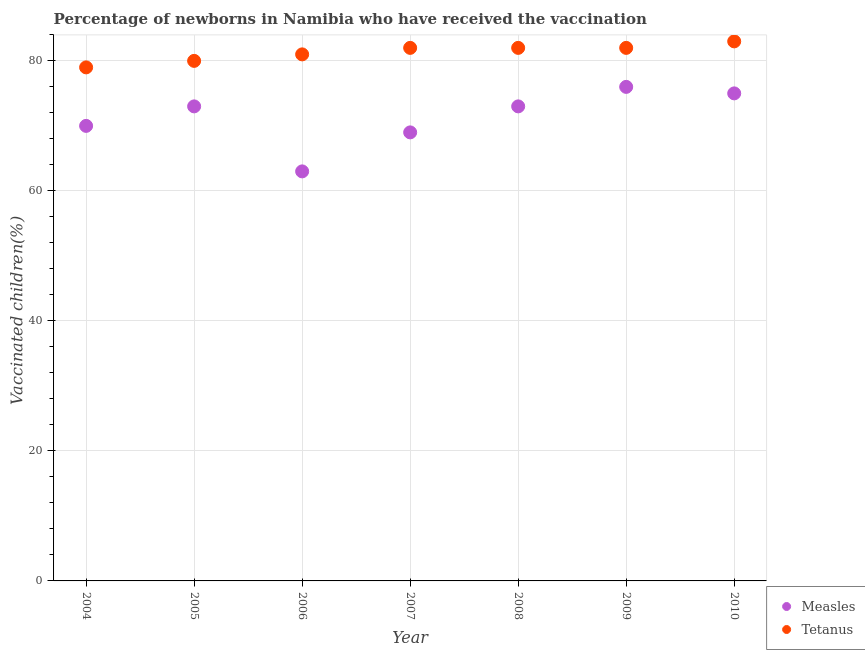Is the number of dotlines equal to the number of legend labels?
Offer a very short reply. Yes. What is the percentage of newborns who received vaccination for tetanus in 2006?
Ensure brevity in your answer.  81. Across all years, what is the maximum percentage of newborns who received vaccination for measles?
Provide a short and direct response. 76. Across all years, what is the minimum percentage of newborns who received vaccination for measles?
Give a very brief answer. 63. In which year was the percentage of newborns who received vaccination for tetanus maximum?
Your answer should be compact. 2010. In which year was the percentage of newborns who received vaccination for measles minimum?
Your answer should be very brief. 2006. What is the total percentage of newborns who received vaccination for measles in the graph?
Provide a succinct answer. 499. What is the difference between the percentage of newborns who received vaccination for tetanus in 2006 and that in 2009?
Give a very brief answer. -1. What is the difference between the percentage of newborns who received vaccination for measles in 2010 and the percentage of newborns who received vaccination for tetanus in 2005?
Offer a terse response. -5. What is the average percentage of newborns who received vaccination for measles per year?
Keep it short and to the point. 71.29. In the year 2009, what is the difference between the percentage of newborns who received vaccination for measles and percentage of newborns who received vaccination for tetanus?
Your answer should be compact. -6. What is the ratio of the percentage of newborns who received vaccination for measles in 2007 to that in 2010?
Your answer should be compact. 0.92. Is the percentage of newborns who received vaccination for measles in 2008 less than that in 2009?
Ensure brevity in your answer.  Yes. What is the difference between the highest and the second highest percentage of newborns who received vaccination for tetanus?
Offer a terse response. 1. What is the difference between the highest and the lowest percentage of newborns who received vaccination for measles?
Offer a terse response. 13. Is the sum of the percentage of newborns who received vaccination for measles in 2008 and 2009 greater than the maximum percentage of newborns who received vaccination for tetanus across all years?
Provide a short and direct response. Yes. Is the percentage of newborns who received vaccination for measles strictly less than the percentage of newborns who received vaccination for tetanus over the years?
Give a very brief answer. Yes. Are the values on the major ticks of Y-axis written in scientific E-notation?
Keep it short and to the point. No. Does the graph contain grids?
Your response must be concise. Yes. How are the legend labels stacked?
Your answer should be very brief. Vertical. What is the title of the graph?
Your answer should be very brief. Percentage of newborns in Namibia who have received the vaccination. Does "Urban" appear as one of the legend labels in the graph?
Offer a very short reply. No. What is the label or title of the X-axis?
Keep it short and to the point. Year. What is the label or title of the Y-axis?
Provide a short and direct response. Vaccinated children(%)
. What is the Vaccinated children(%)
 in Measles in 2004?
Ensure brevity in your answer.  70. What is the Vaccinated children(%)
 of Tetanus in 2004?
Keep it short and to the point. 79. What is the Vaccinated children(%)
 in Measles in 2005?
Give a very brief answer. 73. What is the Vaccinated children(%)
 of Tetanus in 2005?
Keep it short and to the point. 80. What is the Vaccinated children(%)
 of Tetanus in 2008?
Your answer should be very brief. 82. What is the Vaccinated children(%)
 of Tetanus in 2009?
Provide a succinct answer. 82. What is the Vaccinated children(%)
 of Measles in 2010?
Give a very brief answer. 75. What is the Vaccinated children(%)
 of Tetanus in 2010?
Ensure brevity in your answer.  83. Across all years, what is the maximum Vaccinated children(%)
 of Measles?
Provide a short and direct response. 76. Across all years, what is the minimum Vaccinated children(%)
 of Tetanus?
Your answer should be compact. 79. What is the total Vaccinated children(%)
 of Measles in the graph?
Your response must be concise. 499. What is the total Vaccinated children(%)
 in Tetanus in the graph?
Provide a short and direct response. 569. What is the difference between the Vaccinated children(%)
 of Measles in 2004 and that in 2005?
Make the answer very short. -3. What is the difference between the Vaccinated children(%)
 in Tetanus in 2004 and that in 2005?
Ensure brevity in your answer.  -1. What is the difference between the Vaccinated children(%)
 of Tetanus in 2004 and that in 2006?
Offer a very short reply. -2. What is the difference between the Vaccinated children(%)
 of Measles in 2004 and that in 2008?
Ensure brevity in your answer.  -3. What is the difference between the Vaccinated children(%)
 of Measles in 2004 and that in 2009?
Your answer should be compact. -6. What is the difference between the Vaccinated children(%)
 of Tetanus in 2004 and that in 2009?
Provide a succinct answer. -3. What is the difference between the Vaccinated children(%)
 of Tetanus in 2004 and that in 2010?
Provide a short and direct response. -4. What is the difference between the Vaccinated children(%)
 of Measles in 2005 and that in 2006?
Your answer should be very brief. 10. What is the difference between the Vaccinated children(%)
 in Tetanus in 2005 and that in 2007?
Give a very brief answer. -2. What is the difference between the Vaccinated children(%)
 in Tetanus in 2005 and that in 2008?
Offer a terse response. -2. What is the difference between the Vaccinated children(%)
 of Tetanus in 2005 and that in 2009?
Ensure brevity in your answer.  -2. What is the difference between the Vaccinated children(%)
 of Measles in 2005 and that in 2010?
Provide a succinct answer. -2. What is the difference between the Vaccinated children(%)
 of Measles in 2006 and that in 2007?
Provide a succinct answer. -6. What is the difference between the Vaccinated children(%)
 in Tetanus in 2006 and that in 2007?
Ensure brevity in your answer.  -1. What is the difference between the Vaccinated children(%)
 of Measles in 2006 and that in 2008?
Make the answer very short. -10. What is the difference between the Vaccinated children(%)
 of Tetanus in 2006 and that in 2009?
Your answer should be compact. -1. What is the difference between the Vaccinated children(%)
 of Measles in 2007 and that in 2008?
Ensure brevity in your answer.  -4. What is the difference between the Vaccinated children(%)
 in Measles in 2007 and that in 2009?
Provide a succinct answer. -7. What is the difference between the Vaccinated children(%)
 in Tetanus in 2007 and that in 2009?
Give a very brief answer. 0. What is the difference between the Vaccinated children(%)
 in Measles in 2007 and that in 2010?
Keep it short and to the point. -6. What is the difference between the Vaccinated children(%)
 of Tetanus in 2007 and that in 2010?
Offer a very short reply. -1. What is the difference between the Vaccinated children(%)
 in Measles in 2008 and that in 2009?
Your answer should be very brief. -3. What is the difference between the Vaccinated children(%)
 of Measles in 2004 and the Vaccinated children(%)
 of Tetanus in 2005?
Your answer should be compact. -10. What is the difference between the Vaccinated children(%)
 of Measles in 2004 and the Vaccinated children(%)
 of Tetanus in 2006?
Your answer should be compact. -11. What is the difference between the Vaccinated children(%)
 in Measles in 2004 and the Vaccinated children(%)
 in Tetanus in 2007?
Provide a succinct answer. -12. What is the difference between the Vaccinated children(%)
 of Measles in 2004 and the Vaccinated children(%)
 of Tetanus in 2009?
Provide a succinct answer. -12. What is the difference between the Vaccinated children(%)
 of Measles in 2005 and the Vaccinated children(%)
 of Tetanus in 2007?
Provide a succinct answer. -9. What is the difference between the Vaccinated children(%)
 in Measles in 2005 and the Vaccinated children(%)
 in Tetanus in 2010?
Keep it short and to the point. -10. What is the difference between the Vaccinated children(%)
 of Measles in 2006 and the Vaccinated children(%)
 of Tetanus in 2007?
Keep it short and to the point. -19. What is the difference between the Vaccinated children(%)
 of Measles in 2006 and the Vaccinated children(%)
 of Tetanus in 2008?
Provide a short and direct response. -19. What is the difference between the Vaccinated children(%)
 of Measles in 2006 and the Vaccinated children(%)
 of Tetanus in 2009?
Offer a very short reply. -19. What is the difference between the Vaccinated children(%)
 of Measles in 2006 and the Vaccinated children(%)
 of Tetanus in 2010?
Offer a terse response. -20. What is the difference between the Vaccinated children(%)
 of Measles in 2008 and the Vaccinated children(%)
 of Tetanus in 2009?
Make the answer very short. -9. What is the difference between the Vaccinated children(%)
 in Measles in 2009 and the Vaccinated children(%)
 in Tetanus in 2010?
Your answer should be very brief. -7. What is the average Vaccinated children(%)
 in Measles per year?
Ensure brevity in your answer.  71.29. What is the average Vaccinated children(%)
 in Tetanus per year?
Offer a very short reply. 81.29. In the year 2004, what is the difference between the Vaccinated children(%)
 in Measles and Vaccinated children(%)
 in Tetanus?
Give a very brief answer. -9. In the year 2005, what is the difference between the Vaccinated children(%)
 in Measles and Vaccinated children(%)
 in Tetanus?
Ensure brevity in your answer.  -7. In the year 2008, what is the difference between the Vaccinated children(%)
 of Measles and Vaccinated children(%)
 of Tetanus?
Your answer should be compact. -9. In the year 2010, what is the difference between the Vaccinated children(%)
 in Measles and Vaccinated children(%)
 in Tetanus?
Keep it short and to the point. -8. What is the ratio of the Vaccinated children(%)
 in Measles in 2004 to that in 2005?
Make the answer very short. 0.96. What is the ratio of the Vaccinated children(%)
 in Tetanus in 2004 to that in 2005?
Your response must be concise. 0.99. What is the ratio of the Vaccinated children(%)
 of Tetanus in 2004 to that in 2006?
Your answer should be compact. 0.98. What is the ratio of the Vaccinated children(%)
 in Measles in 2004 to that in 2007?
Offer a very short reply. 1.01. What is the ratio of the Vaccinated children(%)
 in Tetanus in 2004 to that in 2007?
Your answer should be very brief. 0.96. What is the ratio of the Vaccinated children(%)
 in Measles in 2004 to that in 2008?
Your response must be concise. 0.96. What is the ratio of the Vaccinated children(%)
 in Tetanus in 2004 to that in 2008?
Offer a very short reply. 0.96. What is the ratio of the Vaccinated children(%)
 in Measles in 2004 to that in 2009?
Offer a very short reply. 0.92. What is the ratio of the Vaccinated children(%)
 in Tetanus in 2004 to that in 2009?
Offer a terse response. 0.96. What is the ratio of the Vaccinated children(%)
 in Measles in 2004 to that in 2010?
Keep it short and to the point. 0.93. What is the ratio of the Vaccinated children(%)
 of Tetanus in 2004 to that in 2010?
Keep it short and to the point. 0.95. What is the ratio of the Vaccinated children(%)
 in Measles in 2005 to that in 2006?
Make the answer very short. 1.16. What is the ratio of the Vaccinated children(%)
 of Tetanus in 2005 to that in 2006?
Your answer should be very brief. 0.99. What is the ratio of the Vaccinated children(%)
 of Measles in 2005 to that in 2007?
Your response must be concise. 1.06. What is the ratio of the Vaccinated children(%)
 in Tetanus in 2005 to that in 2007?
Provide a short and direct response. 0.98. What is the ratio of the Vaccinated children(%)
 of Measles in 2005 to that in 2008?
Your response must be concise. 1. What is the ratio of the Vaccinated children(%)
 in Tetanus in 2005 to that in 2008?
Your answer should be compact. 0.98. What is the ratio of the Vaccinated children(%)
 in Measles in 2005 to that in 2009?
Offer a terse response. 0.96. What is the ratio of the Vaccinated children(%)
 in Tetanus in 2005 to that in 2009?
Your answer should be compact. 0.98. What is the ratio of the Vaccinated children(%)
 in Measles in 2005 to that in 2010?
Ensure brevity in your answer.  0.97. What is the ratio of the Vaccinated children(%)
 of Tetanus in 2005 to that in 2010?
Offer a very short reply. 0.96. What is the ratio of the Vaccinated children(%)
 of Measles in 2006 to that in 2007?
Provide a short and direct response. 0.91. What is the ratio of the Vaccinated children(%)
 in Tetanus in 2006 to that in 2007?
Provide a succinct answer. 0.99. What is the ratio of the Vaccinated children(%)
 in Measles in 2006 to that in 2008?
Offer a very short reply. 0.86. What is the ratio of the Vaccinated children(%)
 in Tetanus in 2006 to that in 2008?
Your response must be concise. 0.99. What is the ratio of the Vaccinated children(%)
 of Measles in 2006 to that in 2009?
Offer a terse response. 0.83. What is the ratio of the Vaccinated children(%)
 of Tetanus in 2006 to that in 2009?
Offer a terse response. 0.99. What is the ratio of the Vaccinated children(%)
 of Measles in 2006 to that in 2010?
Keep it short and to the point. 0.84. What is the ratio of the Vaccinated children(%)
 of Tetanus in 2006 to that in 2010?
Ensure brevity in your answer.  0.98. What is the ratio of the Vaccinated children(%)
 of Measles in 2007 to that in 2008?
Provide a succinct answer. 0.95. What is the ratio of the Vaccinated children(%)
 of Tetanus in 2007 to that in 2008?
Offer a very short reply. 1. What is the ratio of the Vaccinated children(%)
 of Measles in 2007 to that in 2009?
Provide a succinct answer. 0.91. What is the ratio of the Vaccinated children(%)
 of Measles in 2008 to that in 2009?
Provide a succinct answer. 0.96. What is the ratio of the Vaccinated children(%)
 of Tetanus in 2008 to that in 2009?
Provide a short and direct response. 1. What is the ratio of the Vaccinated children(%)
 of Measles in 2008 to that in 2010?
Keep it short and to the point. 0.97. What is the ratio of the Vaccinated children(%)
 of Measles in 2009 to that in 2010?
Provide a succinct answer. 1.01. What is the ratio of the Vaccinated children(%)
 of Tetanus in 2009 to that in 2010?
Your response must be concise. 0.99. What is the difference between the highest and the lowest Vaccinated children(%)
 of Measles?
Offer a very short reply. 13. 